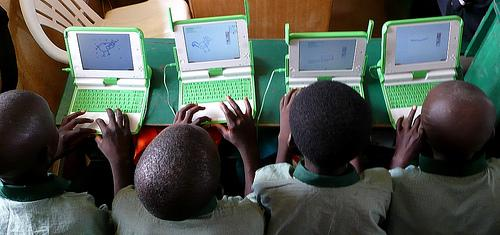Detail the primary activity taking place in the image. Four black children using green and white laptops, sitting together as they learn and engage with the computers. What accessory can be seen in the student's left hand? The left hand of one of the students is holding the green and white laptop, guiding their learning experience. In simple words, describe the main objects used by the children. The children are using small, green and white laptops to work and learn. Describe a color combination noticeable on one of the kid's shirts. A kid is wearing a green and grey shirt, bringing a fashionable mixture of hues to the image. Can you identify the type of hair of two of the students? One of the students has a bald head, and the other has black hair. Mention a notable fashion detail about one of the students. One of the students is wearing a grey and green shirt, showcasing a unique blend of colors and style. State a feature of one of the laptops that connects it to a power source. There is a white power cord coming from one of the laptops for electricity hookup. Is there any furniture present in the image that is essential for the children's posture and comfort?  Yes, there is a white plastic chair next to the small green table, for students to sit on and work comfortably. Tell something unique about one of the.student's physical appearance. One of the students has a bald head, which stands out among the other children. Explain the main focus of the image, along with some key details about the environment. The photo highlights four black children using laptops, surrounded by white chairs and a small green table in an educational setting. 